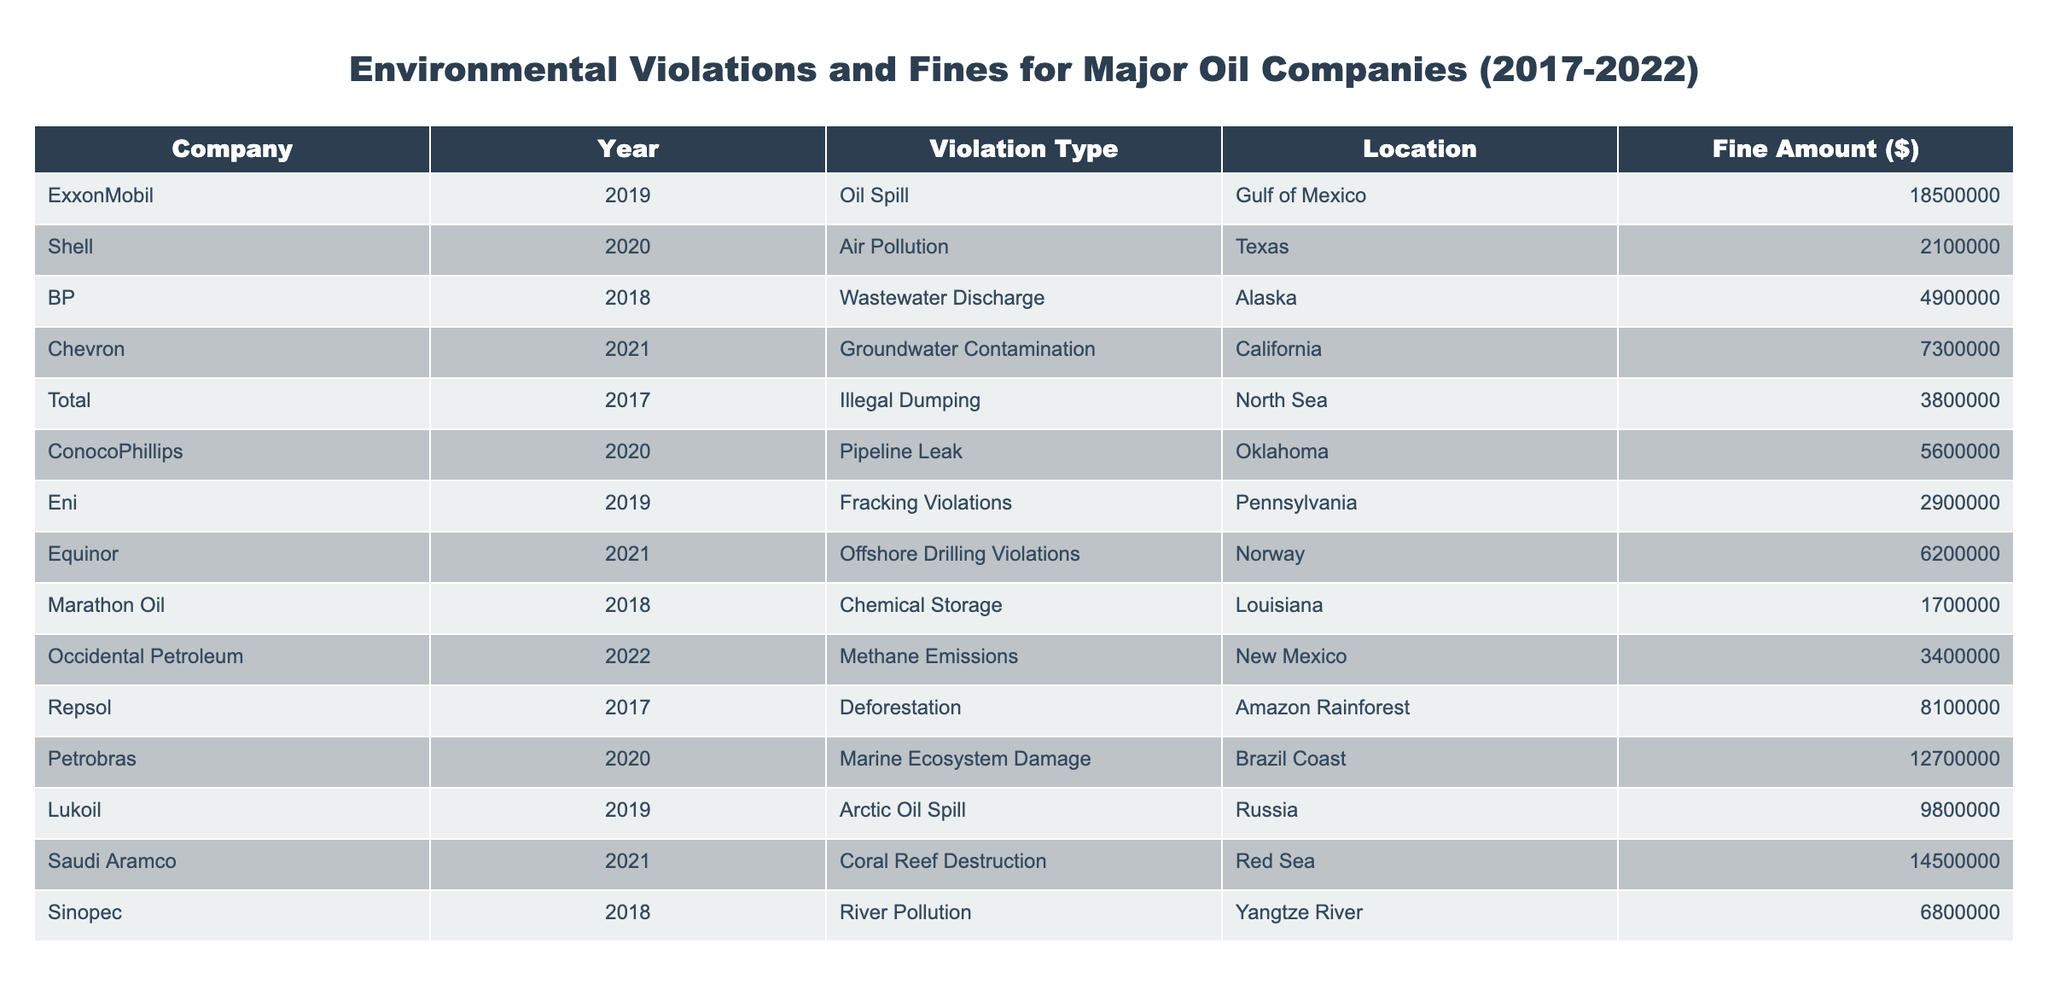What is the total fine amount for ExxonMobil? The fine amount for ExxonMobil in the table is $18,500,000. Since there is only one entry for this company, the total fine is simply that amount.
Answer: 18500000 Which company was fined for groundwater contamination? Looking at the violation type in the table, Chevron is listed with the violation type of groundwater contamination and a fine amount of $7,300,000.
Answer: Chevron What is the average fine amount for violations listed in the table? To find the average fine, we first add all the fine amounts: 18500000 + 2100000 + 4900000 + 7300000 + 3800000 + 5600000 + 2900000 + 6200000 + 1700000 + 3400000 + 8100000 + 12700000 + 9800000 + 14500000 + 6800000 = 109600000. There are 15 data points, so we divide the total by 15: 109600000 / 15 = 7306666.67.
Answer: 7306666.67 Did any company receive a fine for illegal dumping? Yes, Total was fined for illegal dumping in the North Sea, receiving a fine of $3,800,000.
Answer: Yes What are the total fines for the companies based in the United States? The companies based in the U.S. are ExxonMobil, Shell, Chevron, ConocoPhillips, Marathon Oil, and Occidental Petroleum. Their respective fines are summed: 18500000 + 2100000 + 7300000 + 5600000 + 1700000 + 3400000 = 32700000.
Answer: 32700000 Which violation type had the highest single fine amount? Reviewing the fine amounts, Saudi Aramco’s coral reef destruction had the highest fine at $14,500,000 compared to other violations.
Answer: Coral Reef Destruction What is the total fine from violations related to pollution (Air, Water, and Soil)? Identifying pollution-related violations, we find: Air Pollution ($2,100,000), Wastewater Discharge ($4,900,000), Groundwater Contamination ($7,300,000), River Pollution ($6,800,000), and Methane Emissions ($3,400,000). Summing these gives: 2100000 + 4900000 + 7300000 + 6800000 + 3400000 = 26,600,000.
Answer: 26600000 Was Eni fined for violations? Yes, Eni was fined for fracking violations in Pennsylvania with a fine amount of $2,900,000.
Answer: Yes How many companies received fines in 2020? The companies fined in 2020 are Shell, ConocoPhillips, and Petrobras, which totals 3 fines for that year, as seen in the table.
Answer: 3 